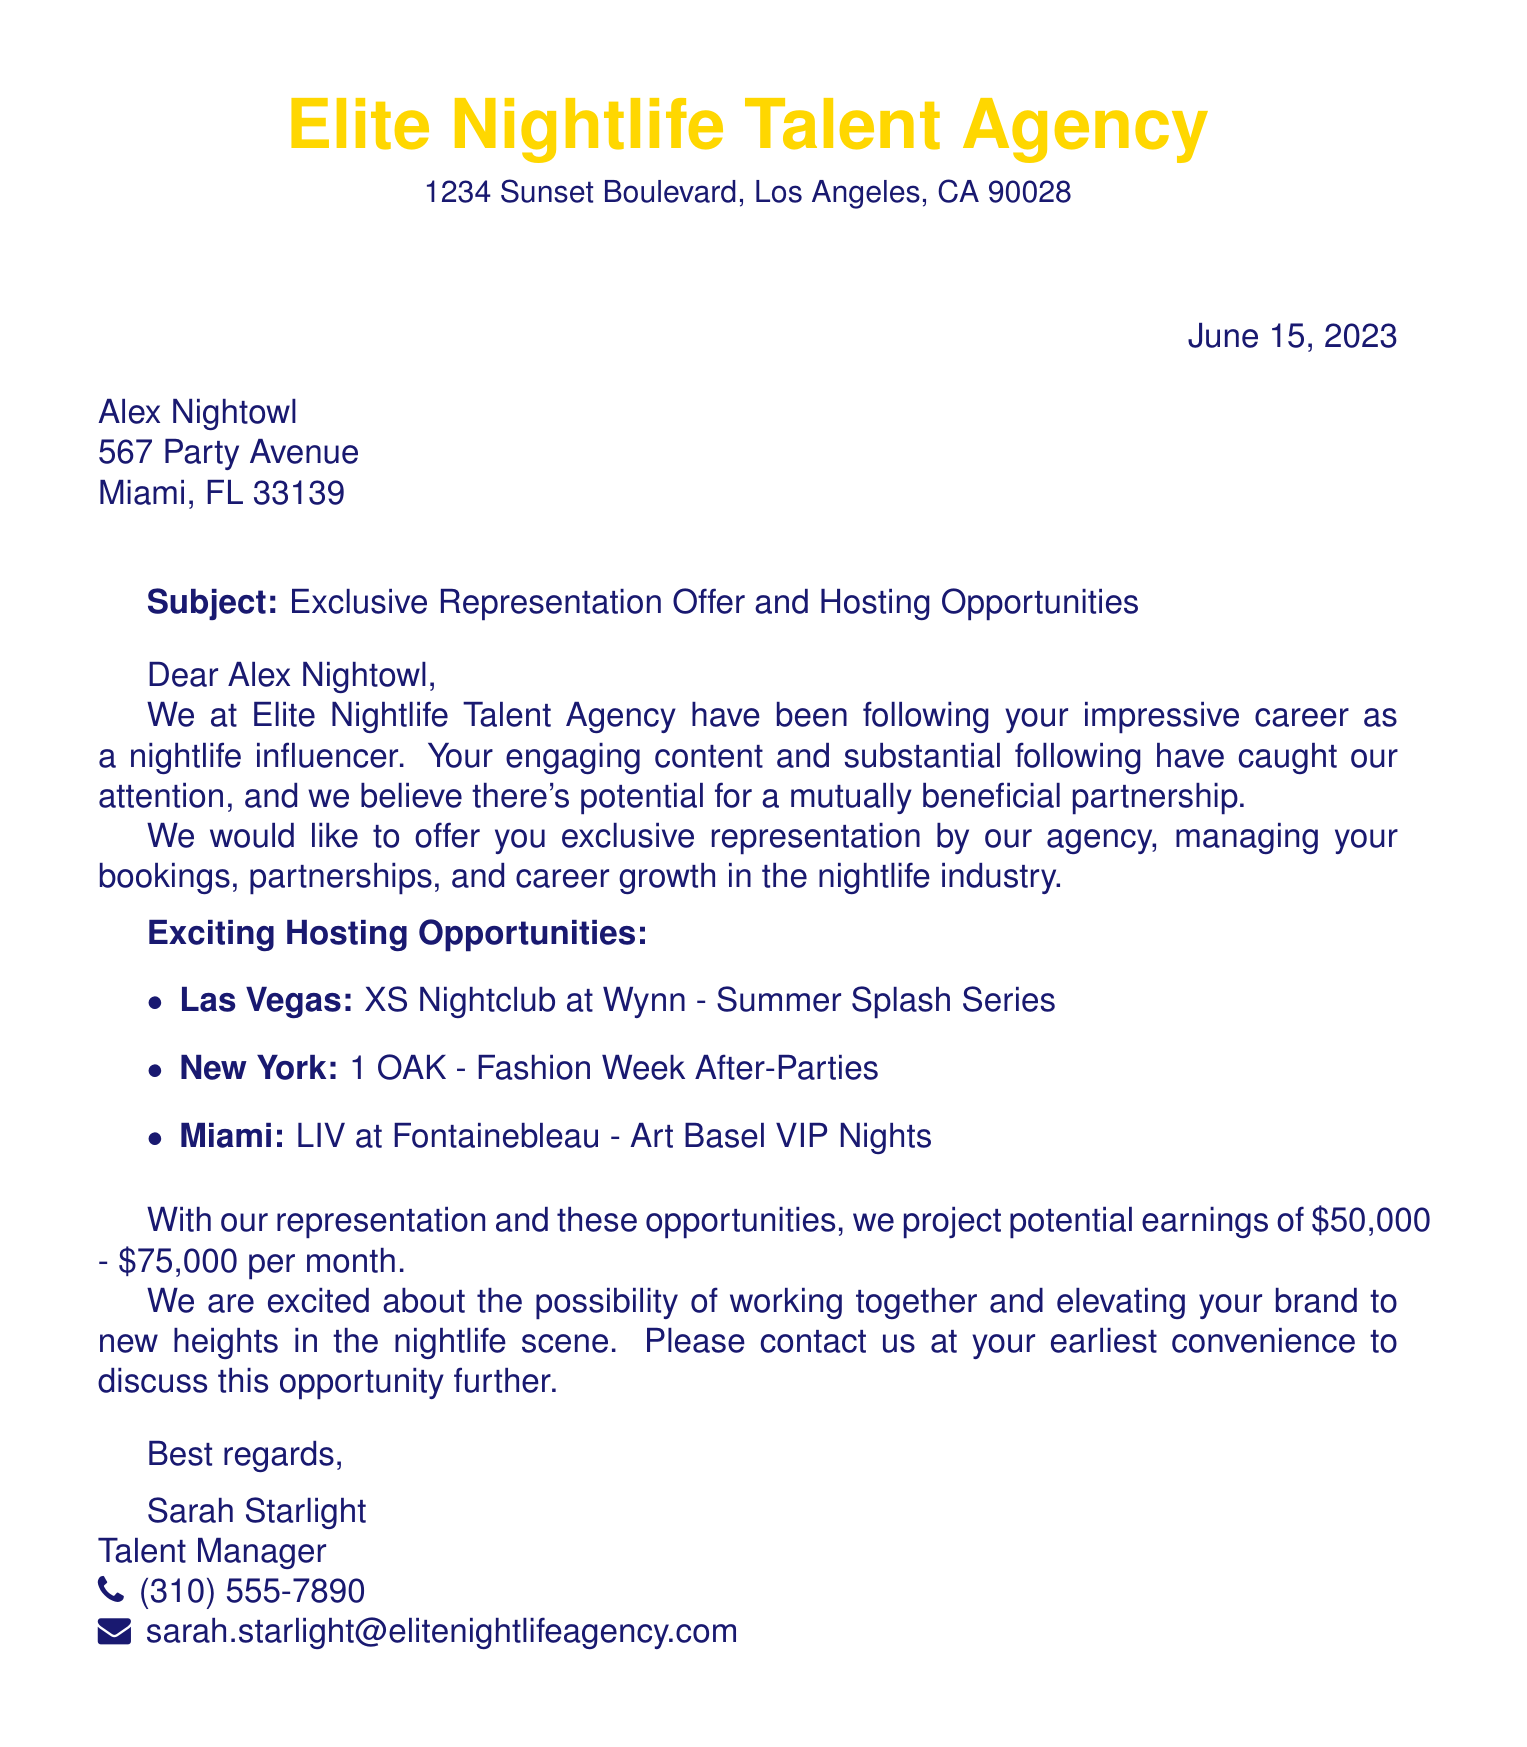what is the name of the agency? The name of the agency is found in the header of the document, which states "Elite Nightlife Talent Agency".
Answer: Elite Nightlife Talent Agency who is the recipient of the fax? The recipient's name is mentioned at the beginning of the document in the address section.
Answer: Alex Nightowl what is the date of the fax? The date can be seen in the top right corner of the fax, indicating when it was sent.
Answer: June 15, 2023 what cities are mentioned for hosting opportunities? The document lists specific cities where hosting opportunities are available, which can be counted.
Answer: Las Vegas, New York, Miami what is the projected potential monthly earnings? The section on potential earnings states a specific range for the earnings the recipient could make.
Answer: $50,000 - $75,000 who is the talent manager? The talent manager's name appears at the end of the document, identified in the closing signature.
Answer: Sarah Starlight what is the subject of the fax? The subject line of the document outlines the primary purpose of the communication.
Answer: Exclusive Representation Offer and Hosting Opportunities which nightclub in Las Vegas is listed? The document specifically names the venue in Las Vegas as part of the hosting opportunities.
Answer: XS Nightclub at Wynn what type of events are associated with the fashion week in New York? The document specifies the type of events related to the New York opportunity.
Answer: Fashion Week After-Parties 